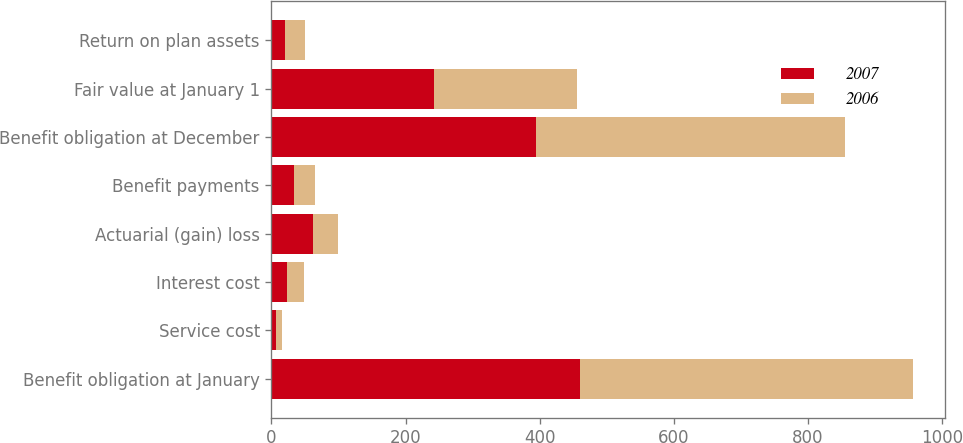Convert chart. <chart><loc_0><loc_0><loc_500><loc_500><stacked_bar_chart><ecel><fcel>Benefit obligation at January<fcel>Service cost<fcel>Interest cost<fcel>Actuarial (gain) loss<fcel>Benefit payments<fcel>Benefit obligation at December<fcel>Fair value at January 1<fcel>Return on plan assets<nl><fcel>2007<fcel>460<fcel>7<fcel>23<fcel>62<fcel>33<fcel>395<fcel>243<fcel>20<nl><fcel>2006<fcel>496<fcel>8<fcel>25<fcel>37<fcel>32<fcel>460<fcel>212<fcel>30<nl></chart> 